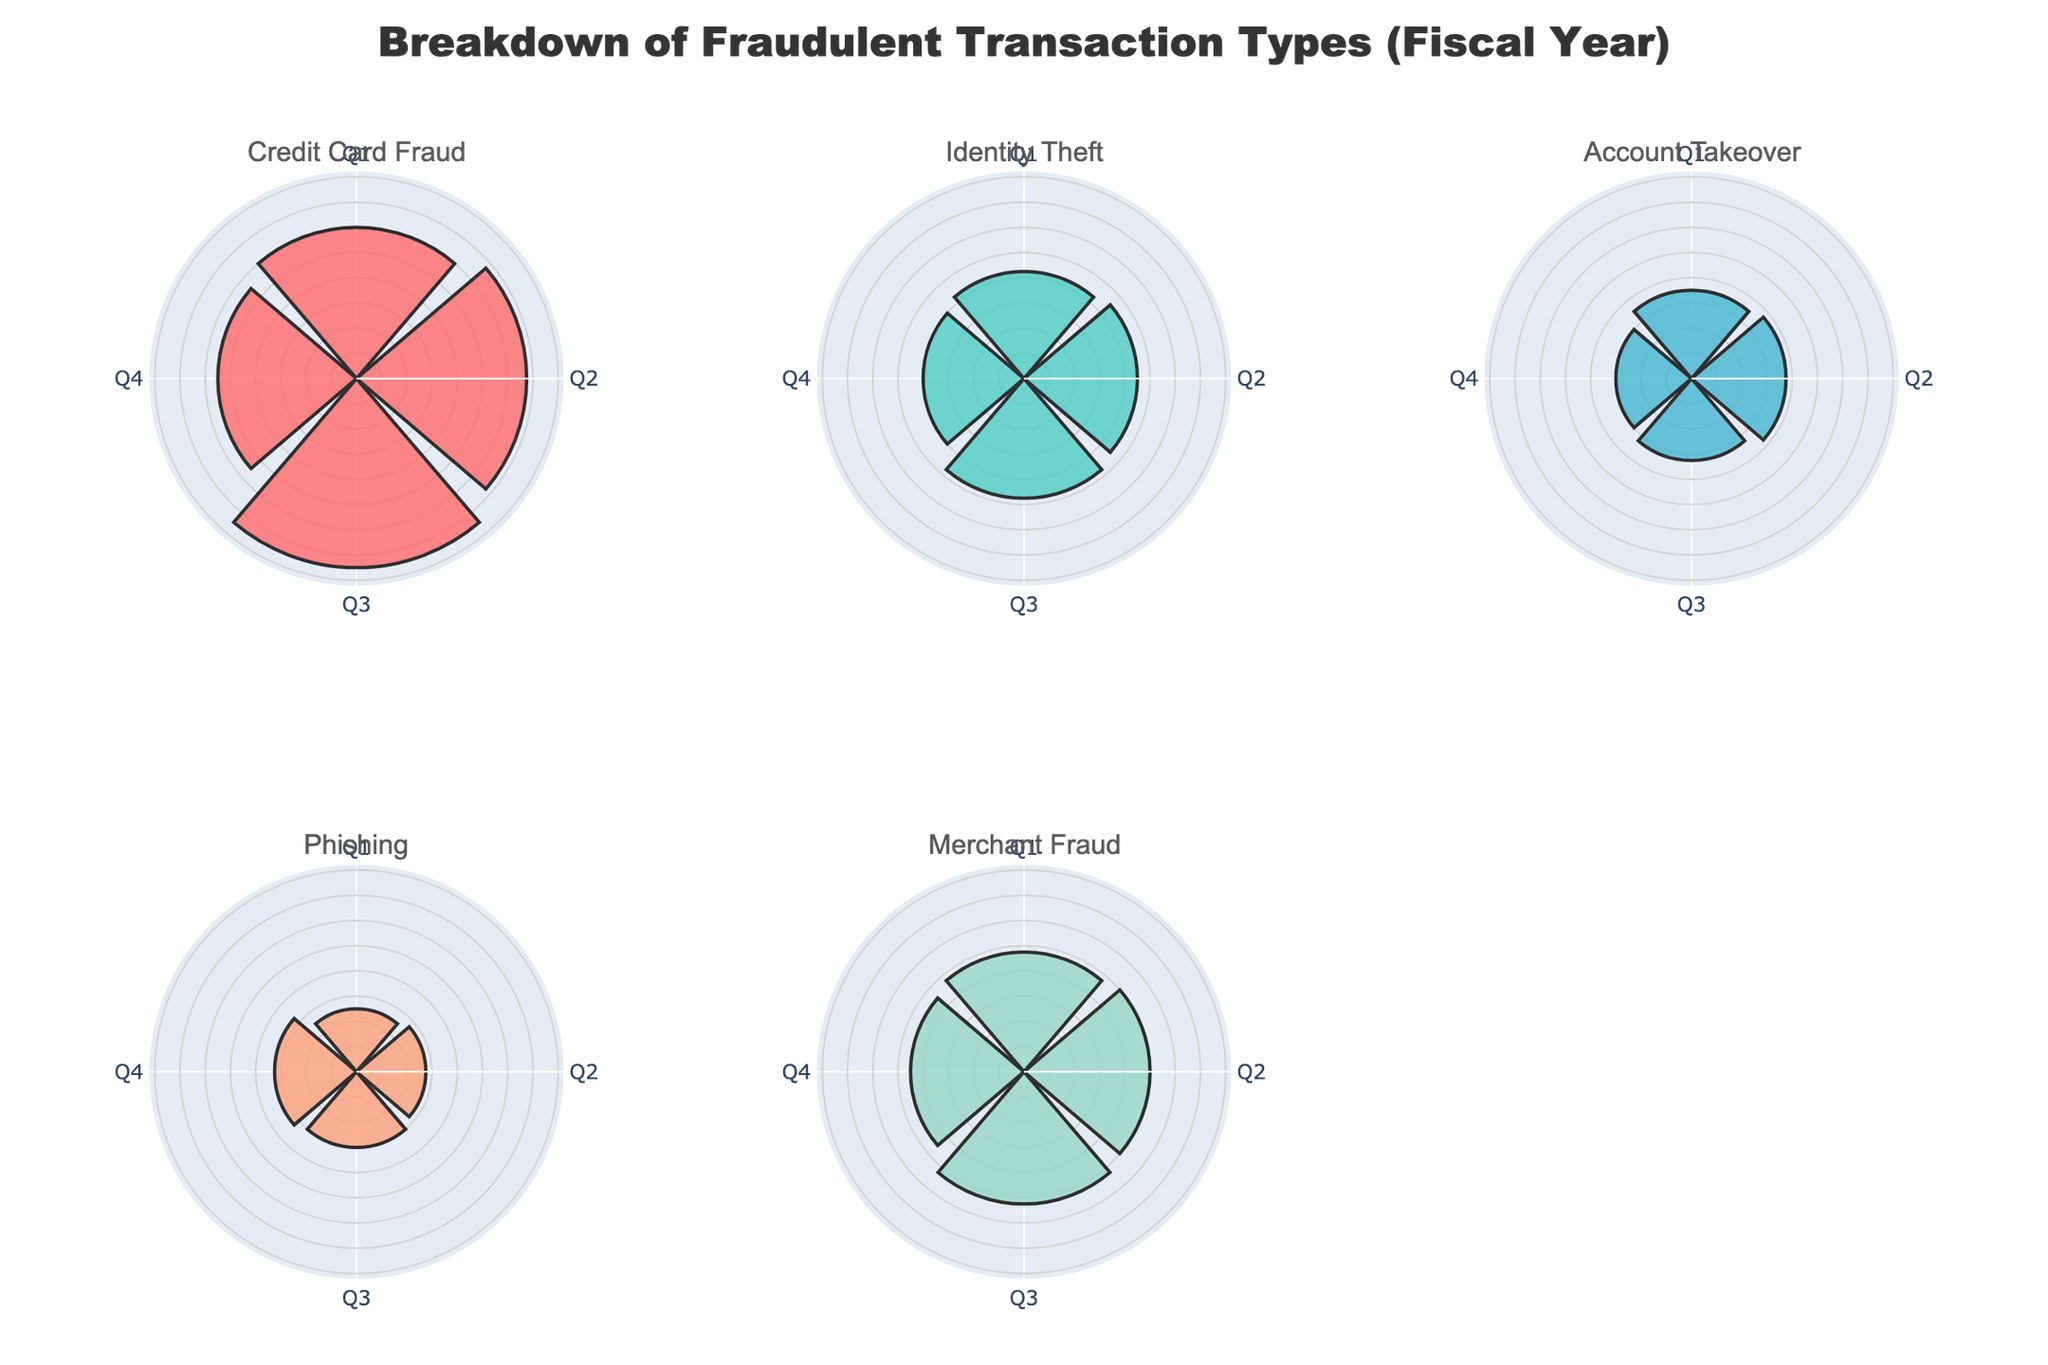What is the title of the figure? The title is displayed at the top of the figure, centered, and it indicates the content of the figure.
Answer: Breakdown of Fraudulent Transaction Types (Fiscal Year) How many different fraudulent transaction types are represented in the figure? Each subplot title names a different fraudulent transaction type, all six subplots have different titles.
Answer: 6 What color represents Identity Theft in the figure? Each subplot is identified by different colors. The color used for Identity Theft can be found in the corresponding subplot.
Answer: Green Which quarter has the highest count of Credit Card Fraud transactions? Look at the Credit Card Fraud subplot and identify which quadrant (Q1 to Q4) has the longest bar.
Answer: Q3 Which two fraudulent transaction types have the closest counts in Q4? Compare the lengths of the bars in each fraudulent transaction type subplot for Q4 and find the ones that are closely matched.
Answer: Account Takeover and Phishing What is the total count of Phishing transactions over all quarters? Sum the values for Phishing from each of the four quarters: Q1 to Q4.
Answer: 230 Which type of fraud shows a decreasing trend over the quarters? Identify the type of fraud where the bars decrease from Q1 to Q4.
Answer: Account Takeover How does the count of Merchant Fraud in Q2 compare to Credit Card Fraud in Q4? Compare the bar heights for Merchant Fraud in Q2 and Credit Card Fraud in Q4.
Answer: Merchant Fraud in Q2 is higher Which quarter shows the lowest count for Identity Theft? Look at the Identity Theft subplot and identify which quarter has the shortest bar.
Answer: Q4 Is there a correlation in the trends between Merchant Fraud and Identity Theft? Observe if the counts of Merchant Fraud and Identity Theft rise or fall similarly over the quarters from their respective subplots.
Answer: No, the trends do not correlate 